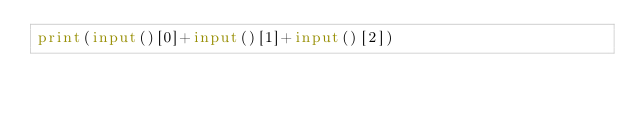<code> <loc_0><loc_0><loc_500><loc_500><_Python_>print(input()[0]+input()[1]+input()[2])</code> 